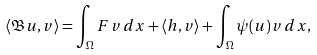<formula> <loc_0><loc_0><loc_500><loc_500>\langle \mathfrak { B } u , v \rangle = \int _ { \Omega } F \, v \, d x + \langle h , v \rangle + \int _ { \Omega } \psi ( u ) \, v \, d x ,</formula> 